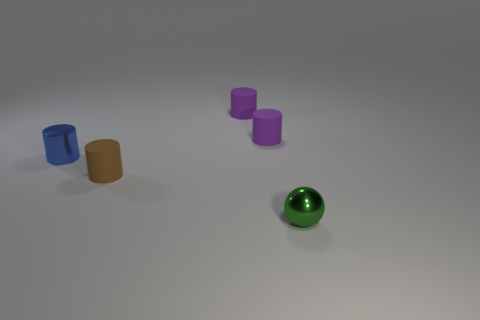Are there the same number of green shiny objects that are in front of the tiny green metallic ball and tiny brown rubber things that are in front of the small brown cylinder?
Keep it short and to the point. Yes. What number of other things are the same size as the sphere?
Provide a succinct answer. 4. Are the tiny green thing and the thing on the left side of the brown rubber object made of the same material?
Your answer should be compact. Yes. Is there a tiny shiny thing of the same shape as the tiny brown rubber thing?
Your answer should be very brief. Yes. There is a blue cylinder that is the same size as the green thing; what is it made of?
Your response must be concise. Metal. Does the metal thing that is in front of the small brown rubber cylinder have the same size as the metallic thing behind the brown thing?
Give a very brief answer. Yes. What number of cyan blocks have the same material as the small blue thing?
Offer a terse response. 0. The sphere has what color?
Make the answer very short. Green. Are there any blue shiny cylinders behind the metallic sphere?
Keep it short and to the point. Yes. There is a matte thing in front of the shiny object that is on the left side of the small green metallic thing; how big is it?
Ensure brevity in your answer.  Small. 